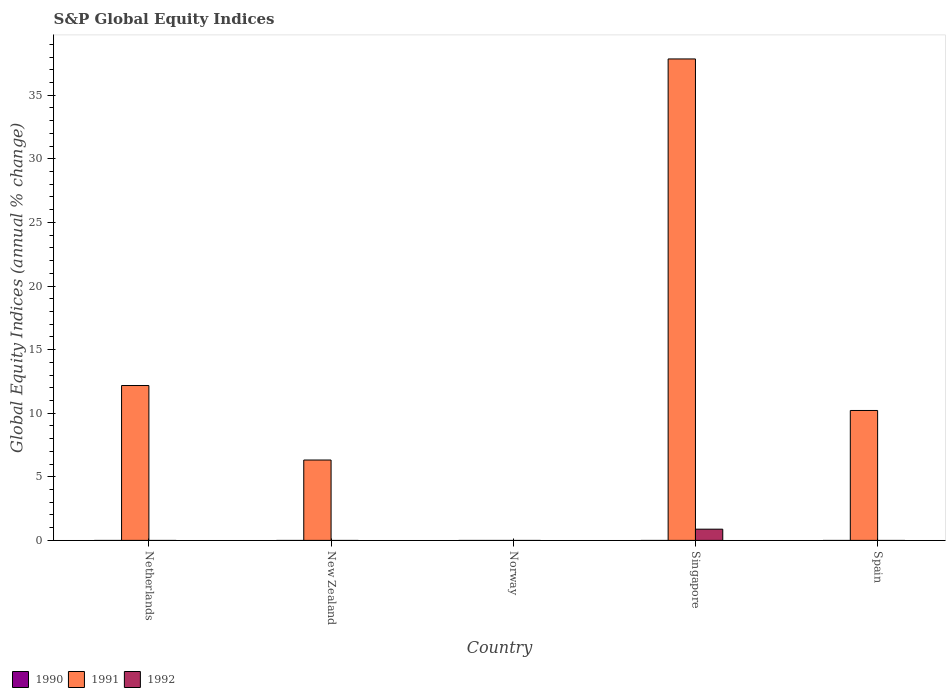Are the number of bars per tick equal to the number of legend labels?
Your answer should be very brief. No. Across all countries, what is the maximum global equity indices in 1991?
Offer a terse response. 37.85. In which country was the global equity indices in 1991 maximum?
Give a very brief answer. Singapore. What is the total global equity indices in 1992 in the graph?
Give a very brief answer. 0.88. What is the difference between the global equity indices in 1991 in Netherlands and that in Spain?
Provide a succinct answer. 1.96. What is the average global equity indices in 1990 per country?
Your answer should be compact. 0. What is the difference between the global equity indices of/in 1992 and global equity indices of/in 1991 in Singapore?
Offer a terse response. -36.97. What is the ratio of the global equity indices in 1991 in Netherlands to that in New Zealand?
Make the answer very short. 1.93. What is the difference between the highest and the second highest global equity indices in 1991?
Your answer should be compact. -1.96. What is the difference between the highest and the lowest global equity indices in 1992?
Provide a short and direct response. 0.88. In how many countries, is the global equity indices in 1992 greater than the average global equity indices in 1992 taken over all countries?
Offer a terse response. 1. How many bars are there?
Provide a short and direct response. 5. Are all the bars in the graph horizontal?
Offer a very short reply. No. How many countries are there in the graph?
Ensure brevity in your answer.  5. What is the difference between two consecutive major ticks on the Y-axis?
Make the answer very short. 5. Are the values on the major ticks of Y-axis written in scientific E-notation?
Your response must be concise. No. Does the graph contain grids?
Your response must be concise. No. What is the title of the graph?
Make the answer very short. S&P Global Equity Indices. Does "1964" appear as one of the legend labels in the graph?
Your answer should be compact. No. What is the label or title of the Y-axis?
Offer a terse response. Global Equity Indices (annual % change). What is the Global Equity Indices (annual % change) in 1991 in Netherlands?
Keep it short and to the point. 12.18. What is the Global Equity Indices (annual % change) of 1991 in New Zealand?
Your response must be concise. 6.32. What is the Global Equity Indices (annual % change) in 1991 in Norway?
Ensure brevity in your answer.  0. What is the Global Equity Indices (annual % change) of 1992 in Norway?
Your answer should be compact. 0. What is the Global Equity Indices (annual % change) in 1991 in Singapore?
Offer a very short reply. 37.85. What is the Global Equity Indices (annual % change) of 1992 in Singapore?
Keep it short and to the point. 0.88. What is the Global Equity Indices (annual % change) in 1991 in Spain?
Provide a short and direct response. 10.21. What is the Global Equity Indices (annual % change) of 1992 in Spain?
Give a very brief answer. 0. Across all countries, what is the maximum Global Equity Indices (annual % change) in 1991?
Keep it short and to the point. 37.85. Across all countries, what is the maximum Global Equity Indices (annual % change) of 1992?
Your answer should be compact. 0.88. Across all countries, what is the minimum Global Equity Indices (annual % change) in 1991?
Your answer should be compact. 0. What is the total Global Equity Indices (annual % change) in 1990 in the graph?
Provide a succinct answer. 0. What is the total Global Equity Indices (annual % change) in 1991 in the graph?
Offer a very short reply. 66.56. What is the total Global Equity Indices (annual % change) of 1992 in the graph?
Give a very brief answer. 0.88. What is the difference between the Global Equity Indices (annual % change) of 1991 in Netherlands and that in New Zealand?
Give a very brief answer. 5.86. What is the difference between the Global Equity Indices (annual % change) in 1991 in Netherlands and that in Singapore?
Provide a succinct answer. -25.68. What is the difference between the Global Equity Indices (annual % change) in 1991 in Netherlands and that in Spain?
Your answer should be compact. 1.96. What is the difference between the Global Equity Indices (annual % change) of 1991 in New Zealand and that in Singapore?
Give a very brief answer. -31.53. What is the difference between the Global Equity Indices (annual % change) in 1991 in New Zealand and that in Spain?
Provide a short and direct response. -3.9. What is the difference between the Global Equity Indices (annual % change) of 1991 in Singapore and that in Spain?
Your answer should be very brief. 27.64. What is the difference between the Global Equity Indices (annual % change) of 1991 in Netherlands and the Global Equity Indices (annual % change) of 1992 in Singapore?
Your answer should be compact. 11.3. What is the difference between the Global Equity Indices (annual % change) of 1991 in New Zealand and the Global Equity Indices (annual % change) of 1992 in Singapore?
Make the answer very short. 5.44. What is the average Global Equity Indices (annual % change) in 1991 per country?
Offer a terse response. 13.31. What is the average Global Equity Indices (annual % change) in 1992 per country?
Offer a very short reply. 0.18. What is the difference between the Global Equity Indices (annual % change) of 1991 and Global Equity Indices (annual % change) of 1992 in Singapore?
Your response must be concise. 36.97. What is the ratio of the Global Equity Indices (annual % change) of 1991 in Netherlands to that in New Zealand?
Provide a short and direct response. 1.93. What is the ratio of the Global Equity Indices (annual % change) in 1991 in Netherlands to that in Singapore?
Keep it short and to the point. 0.32. What is the ratio of the Global Equity Indices (annual % change) in 1991 in Netherlands to that in Spain?
Offer a very short reply. 1.19. What is the ratio of the Global Equity Indices (annual % change) in 1991 in New Zealand to that in Singapore?
Your answer should be compact. 0.17. What is the ratio of the Global Equity Indices (annual % change) of 1991 in New Zealand to that in Spain?
Your answer should be compact. 0.62. What is the ratio of the Global Equity Indices (annual % change) in 1991 in Singapore to that in Spain?
Provide a short and direct response. 3.71. What is the difference between the highest and the second highest Global Equity Indices (annual % change) in 1991?
Provide a succinct answer. 25.68. What is the difference between the highest and the lowest Global Equity Indices (annual % change) in 1991?
Your answer should be very brief. 37.85. What is the difference between the highest and the lowest Global Equity Indices (annual % change) of 1992?
Your response must be concise. 0.88. 